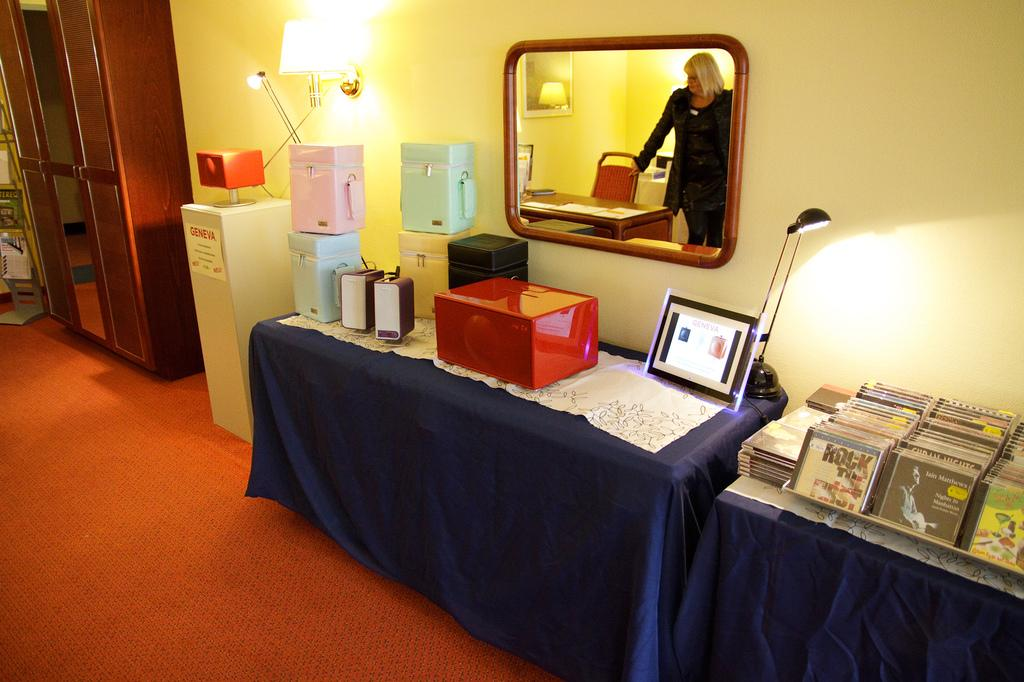<image>
Describe the image concisely. a cd with the word rock on it 